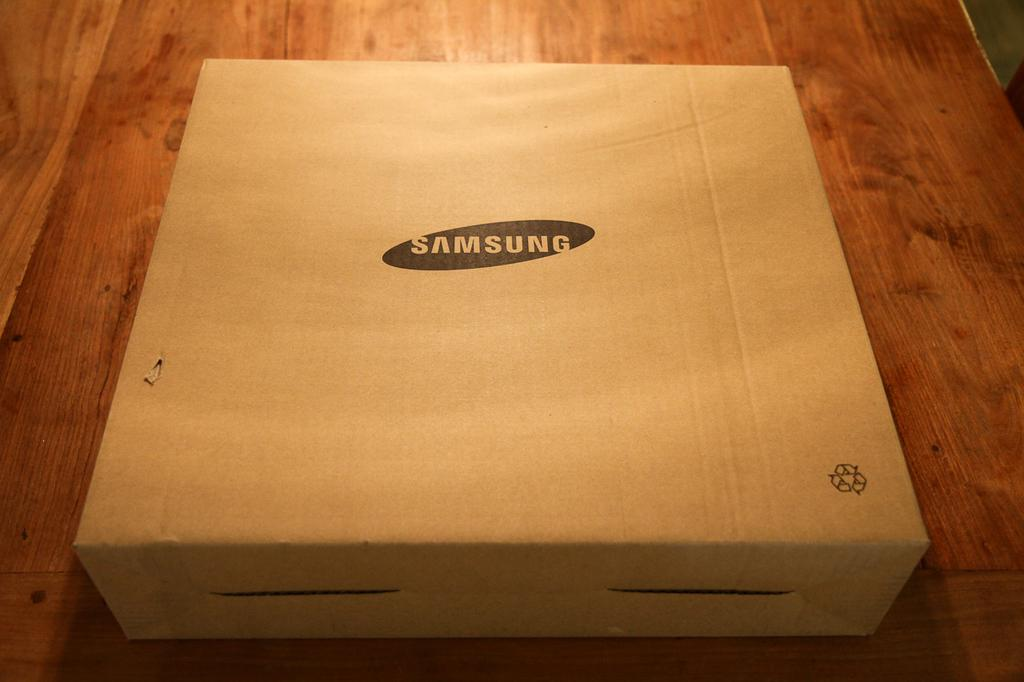<image>
Offer a succinct explanation of the picture presented. A plain cardboard box with a Samsung logo rests on a table. 